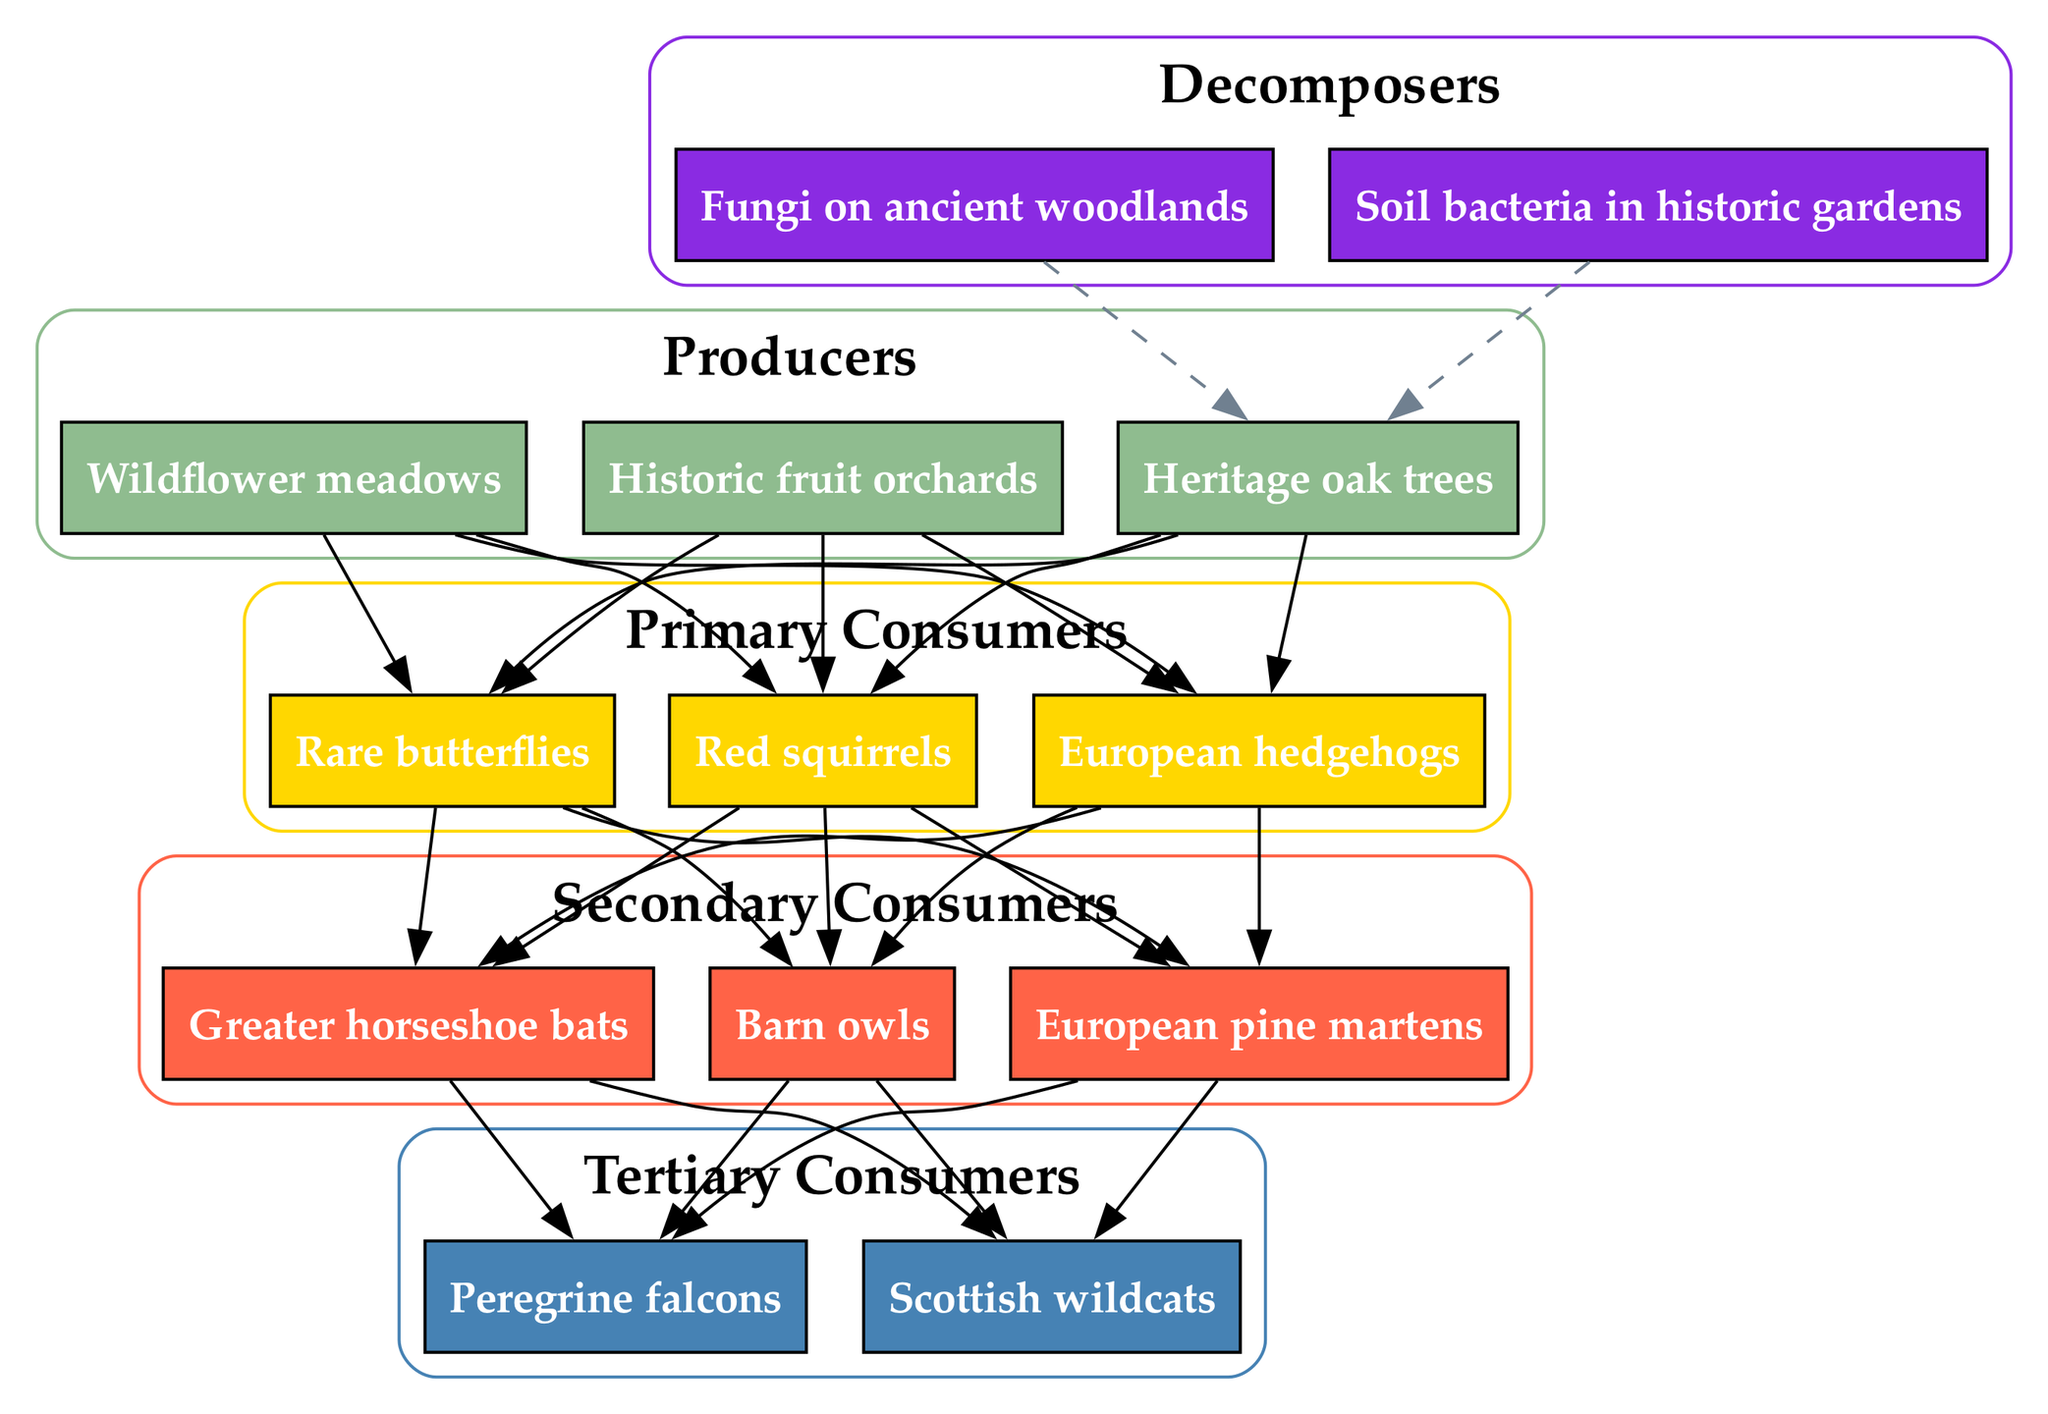What are the producers in the food chain? The producers in the food chain, as indicated in the diagram, are listed under the "Producers" category. They include "Heritage oak trees," "Wildflower meadows," and "Historic fruit orchards."
Answer: Heritage oak trees, Wildflower meadows, Historic fruit orchards How many primary consumers are present? To find the number of primary consumers, we look at the "Primary Consumers" category in the diagram, which lists three items: "Red squirrels," "European hedgehogs," and "Rare butterflies." Thus, the count is determined to be three.
Answer: 3 What do primary consumers primarily feed on? The primary consumers feed on producers, as shown by the directed edges in the diagram from each producer to the primary consumers, indicating that they consume these producers for energy.
Answer: Producers Which tertiary consumer is at the top of the food chain? The tertiary consumers are listed under the "Tertiary Consumers" category, and the diagram visually indicates that "Peregrine falcons" and "Scottish wildcats" are both tertiary consumers. The question regarding the one at the top can refer to the first listed: "Peregrine falcons."
Answer: Peregrine falcons What type of relationship do primary consumers have with secondary consumers? The relationship between primary and secondary consumers in the diagram is indicated by directed edges that connect each primary consumer to the secondary consumers. This shows that primary consumers are preyed upon by secondary consumers, establishing a predator-prey relationship.
Answer: Predator-prey How many decomposers are shown in the diagram? The "Decomposers" category lists two items: "Fungi on ancient woodlands" and "Soil bacteria in historic gardens." Therefore, the count of decomposers is evaluated to be two.
Answer: 2 What is unique about the decomposition process in this food chain? The unique aspect of the decomposition process is represented by the dashed edge from the decomposers back to the producers, indicating that decomposers play a crucial role in returning nutrients to the soil, which ultimately supports the producers in this ecosystem.
Answer: Nutrient recycling Which secondary consumer is associated with barn owls? The diagram shows that barn owls are listed under "Secondary Consumers," but it should be observed that they have directed edges from primary consumers, which indicates they may prey upon any of the three primary consumers. Hence, the secondary consumer associated with barn owls includes all primary consumers in the food chain.
Answer: Red squirrels, European hedgehogs, Rare butterflies Can you name the specific habitats where the producers are found? The specifics regarding the habitats of the producers are inferred from their names in the diagram: the "Heritage oak trees" are found in woodlands, "Wildflower meadows" in meadows, and "Historic fruit orchards" in orchards, all being common habitats in protected areas.
Answer: Woodlands, meadows, orchards 